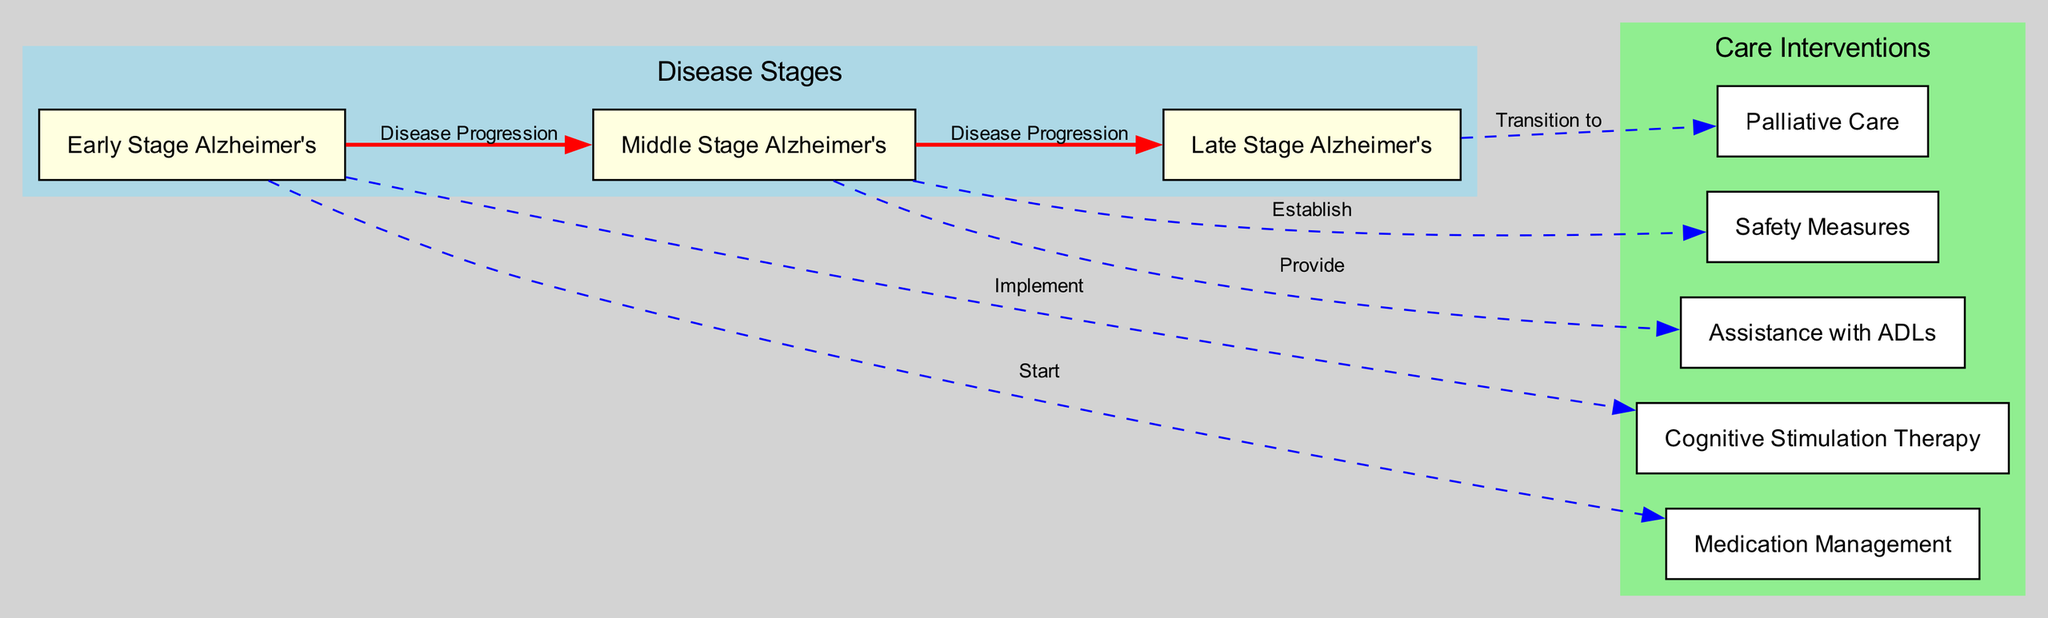What are the three stages of Alzheimer's disease illustrated in the diagram? The diagram lists three stages labeled as "Early Stage Alzheimer's," "Middle Stage Alzheimer's," and "Late Stage Alzheimer's."
Answer: Early Stage Alzheimer's, Middle Stage Alzheimer's, Late Stage Alzheimer's How many care interventions are mentioned in the diagram? The diagram highlights five care interventions. These are "Cognitive Stimulation Therapy," "Medication Management," "Safety Measures," "Assistance with ADLs," and "Palliative Care."
Answer: 5 What is the care intervention implemented in the early stage of Alzheimer's? The diagram indicates that "Cognitive Stimulation Therapy" is implemented in the early stage of Alzheimer's disease.
Answer: Cognitive Stimulation Therapy What progression occurs from Middle Stage Alzheimer's to Late Stage Alzheimer's? According to the diagram, the progression from Middle Stage Alzheimer's to Late Stage Alzheimer's is labeled as "Disease Progression."
Answer: Disease Progression Which care intervention is provided during the Middle Stage Alzheimer's? The diagram states that during the Middle Stage Alzheimer's, two care interventions are established: "Safety Measures" and "Assistance with ADLs."
Answer: Safety Measures, Assistance with ADLs What transition is made in the Late Stage Alzheimer's according to the diagram? The diagram specifies a transition to "Palliative Care" in the Late Stage Alzheimer's stage of the disease.
Answer: Palliative Care Which care intervention starts alongside Early Stage Alzheimer's? The diagram shows that "Medication Management" starts alongside Early Stage Alzheimer's.
Answer: Medication Management What color represents the care interventions in the diagram? The diagram represents the care interventions with the color white.
Answer: White 